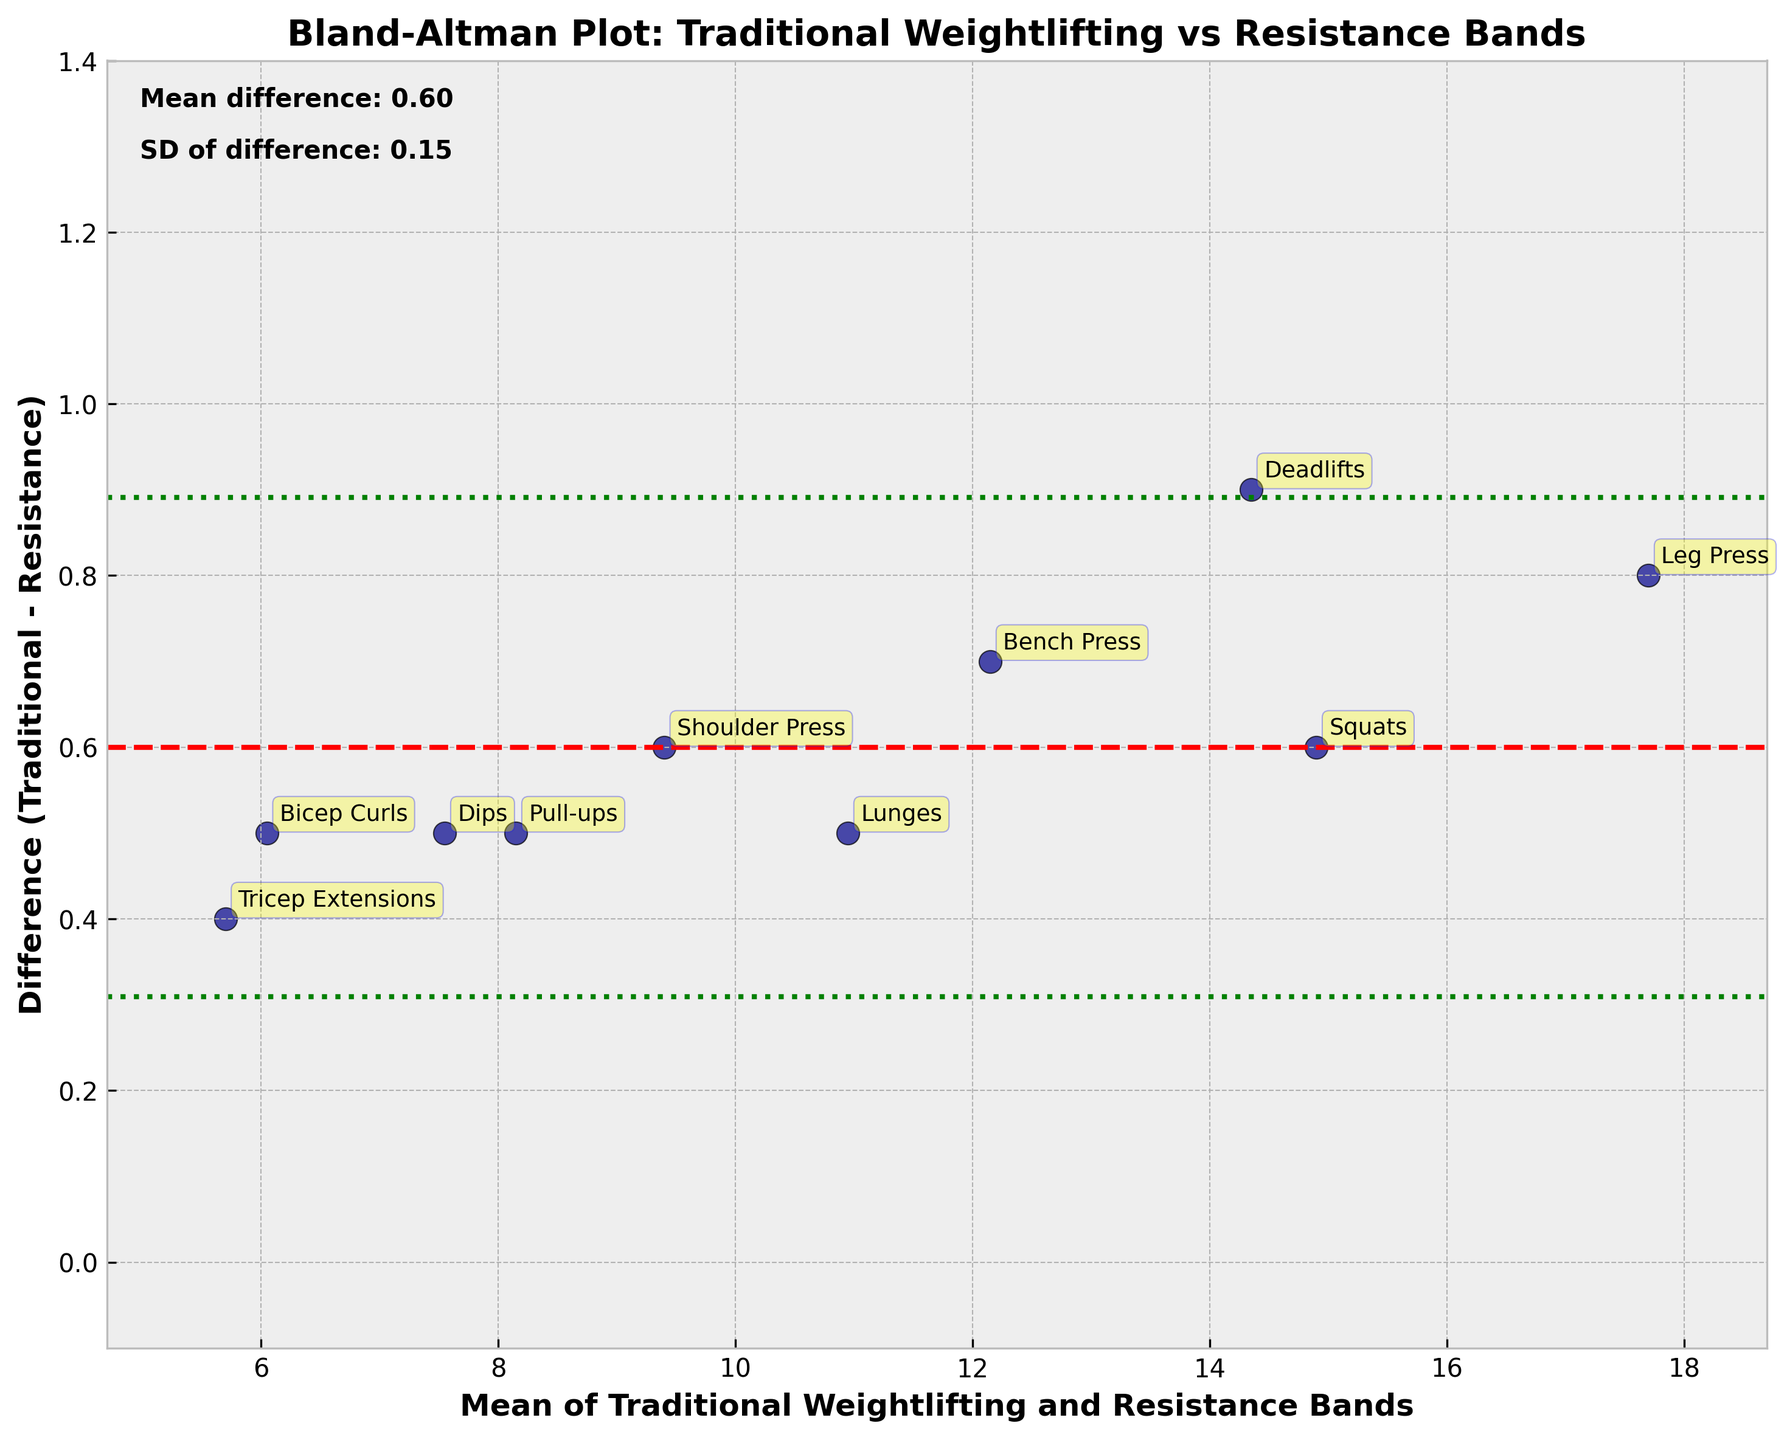What is the title of the plot? The title is displayed at the top of the figure and reads "Bland-Altman Plot: Traditional Weightlifting vs Resistance Bands".
Answer: Bland-Altman Plot: Traditional Weightlifting vs Resistance Bands How many data points are in the plot? Each point on the plot corresponds to one exercise method being compared; by counting these points along with their annotations, you can find there are 10 data points.
Answer: 10 What does the red dashed line represent? In a Bland-Altman plot, the red dashed line at the y-coordinate indicates the mean difference between traditional weightlifting and resistance bands. This line is visually distinct from other lines.
Answer: Mean difference Which exercise method shows the largest difference in muscle gain measurements between traditional weightlifting and resistance bands? To find this, look for the highest point on the y-axis representing the difference value. The largest difference is for Deadlifts, which has a difference of 0.9.
Answer: Deadlifts What do the green dotted lines represent? In Bland-Altman plots, the green dotted lines represent the limits of agreement, calculated as the mean difference plus or minus 1.96 times the standard deviation of the differences. These lines indicate the range within which most differences between the two methods lie.
Answer: Limits of agreement What is the mean difference between traditional weightlifting and resistance bands? This information is provided on the plot near the bottom left, where it states "Mean difference: 0.61".
Answer: 0.61 Which data point has the smallest difference between traditional weightlifting and resistance bands? By observing the lowest point on the y-axis representing the difference value, it is clear that Tricep Extensions have the smallest difference, which is 0.4.
Answer: Tricep Extensions Are all the differences between the two methods within the limits of agreement? Confirm this by ensuring all points fall between the upper and lower green dotted lines, which represent the limits of agreement. Since all points lie within this range, the answer is yes.
Answer: Yes What is the average of the mean values for Bench Press and Squats? The mean values for Bench Press and Squats are approximately 12.15 and 14.90, respectively. Adding these values together gives 27.05, and dividing by 2 yields the average: 27.05 / 2 = 13.525.
Answer: 13.525 